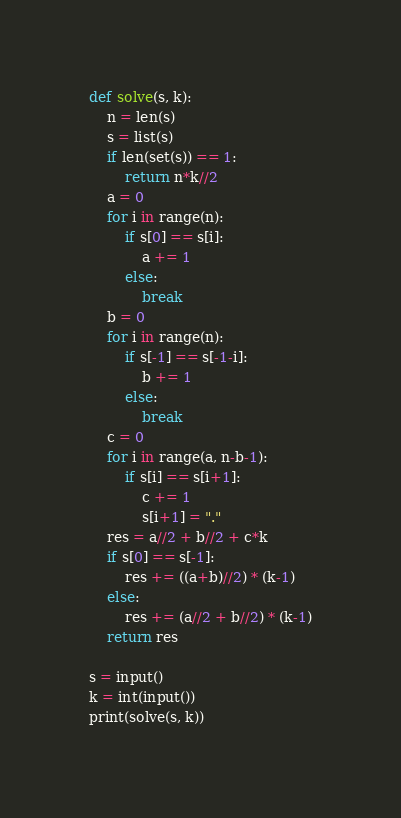<code> <loc_0><loc_0><loc_500><loc_500><_Python_>def solve(s, k):
    n = len(s)
    s = list(s)
    if len(set(s)) == 1:
        return n*k//2
    a = 0
    for i in range(n):
        if s[0] == s[i]:
            a += 1
        else:
            break
    b = 0
    for i in range(n):
        if s[-1] == s[-1-i]:
            b += 1
        else:
            break
    c = 0
    for i in range(a, n-b-1):
        if s[i] == s[i+1]:
            c += 1
            s[i+1] = "."
    res = a//2 + b//2 + c*k
    if s[0] == s[-1]:
        res += ((a+b)//2) * (k-1)
    else:
        res += (a//2 + b//2) * (k-1)
    return res

s = input()
k = int(input())
print(solve(s, k))</code> 